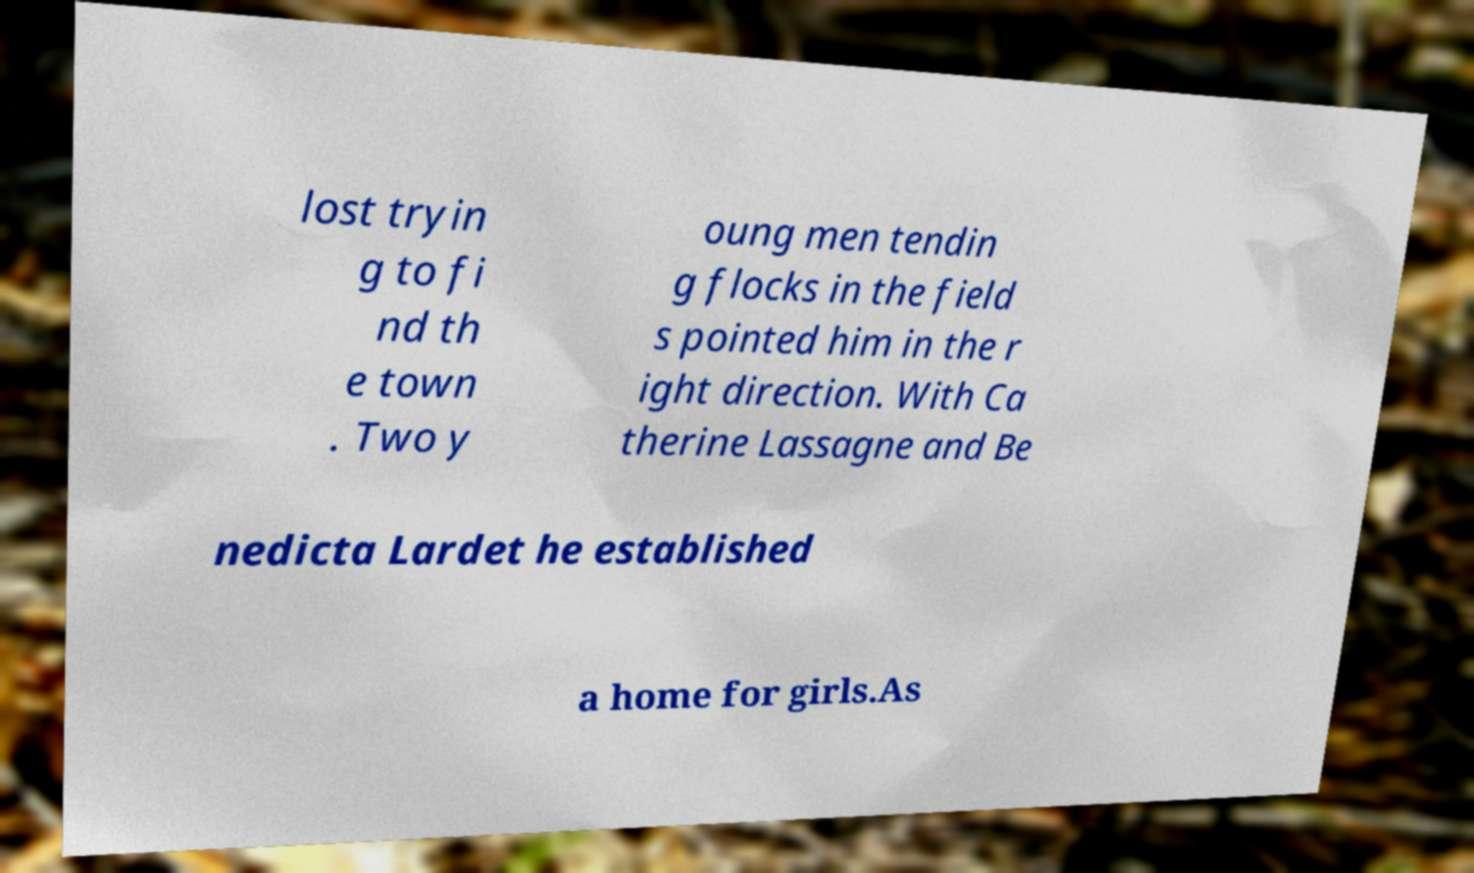Could you assist in decoding the text presented in this image and type it out clearly? lost tryin g to fi nd th e town . Two y oung men tendin g flocks in the field s pointed him in the r ight direction. With Ca therine Lassagne and Be nedicta Lardet he established a home for girls.As 